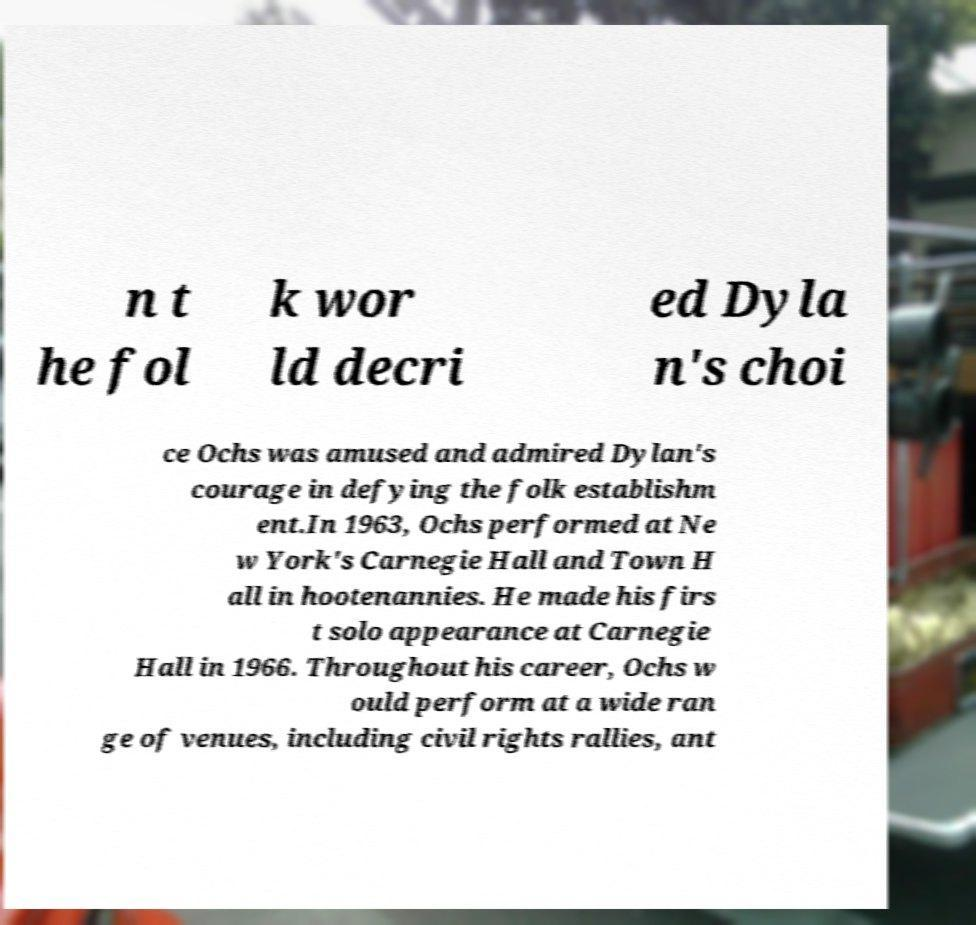Please identify and transcribe the text found in this image. n t he fol k wor ld decri ed Dyla n's choi ce Ochs was amused and admired Dylan's courage in defying the folk establishm ent.In 1963, Ochs performed at Ne w York's Carnegie Hall and Town H all in hootenannies. He made his firs t solo appearance at Carnegie Hall in 1966. Throughout his career, Ochs w ould perform at a wide ran ge of venues, including civil rights rallies, ant 